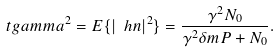Convert formula to latex. <formula><loc_0><loc_0><loc_500><loc_500>\ t g a m m a ^ { 2 } = E \{ | \ h n | ^ { 2 } \} = \frac { \gamma ^ { 2 } N _ { 0 } } { \gamma ^ { 2 } \delta m P + N _ { 0 } } .</formula> 